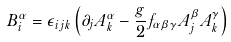Convert formula to latex. <formula><loc_0><loc_0><loc_500><loc_500>B _ { i } ^ { \alpha } = \epsilon _ { i j k } \left ( \partial _ { j } A _ { k } ^ { \alpha } - \frac { g } { 2 } f _ { \alpha \beta \gamma } A _ { j } ^ { \beta } A _ { k } ^ { \gamma } \right )</formula> 